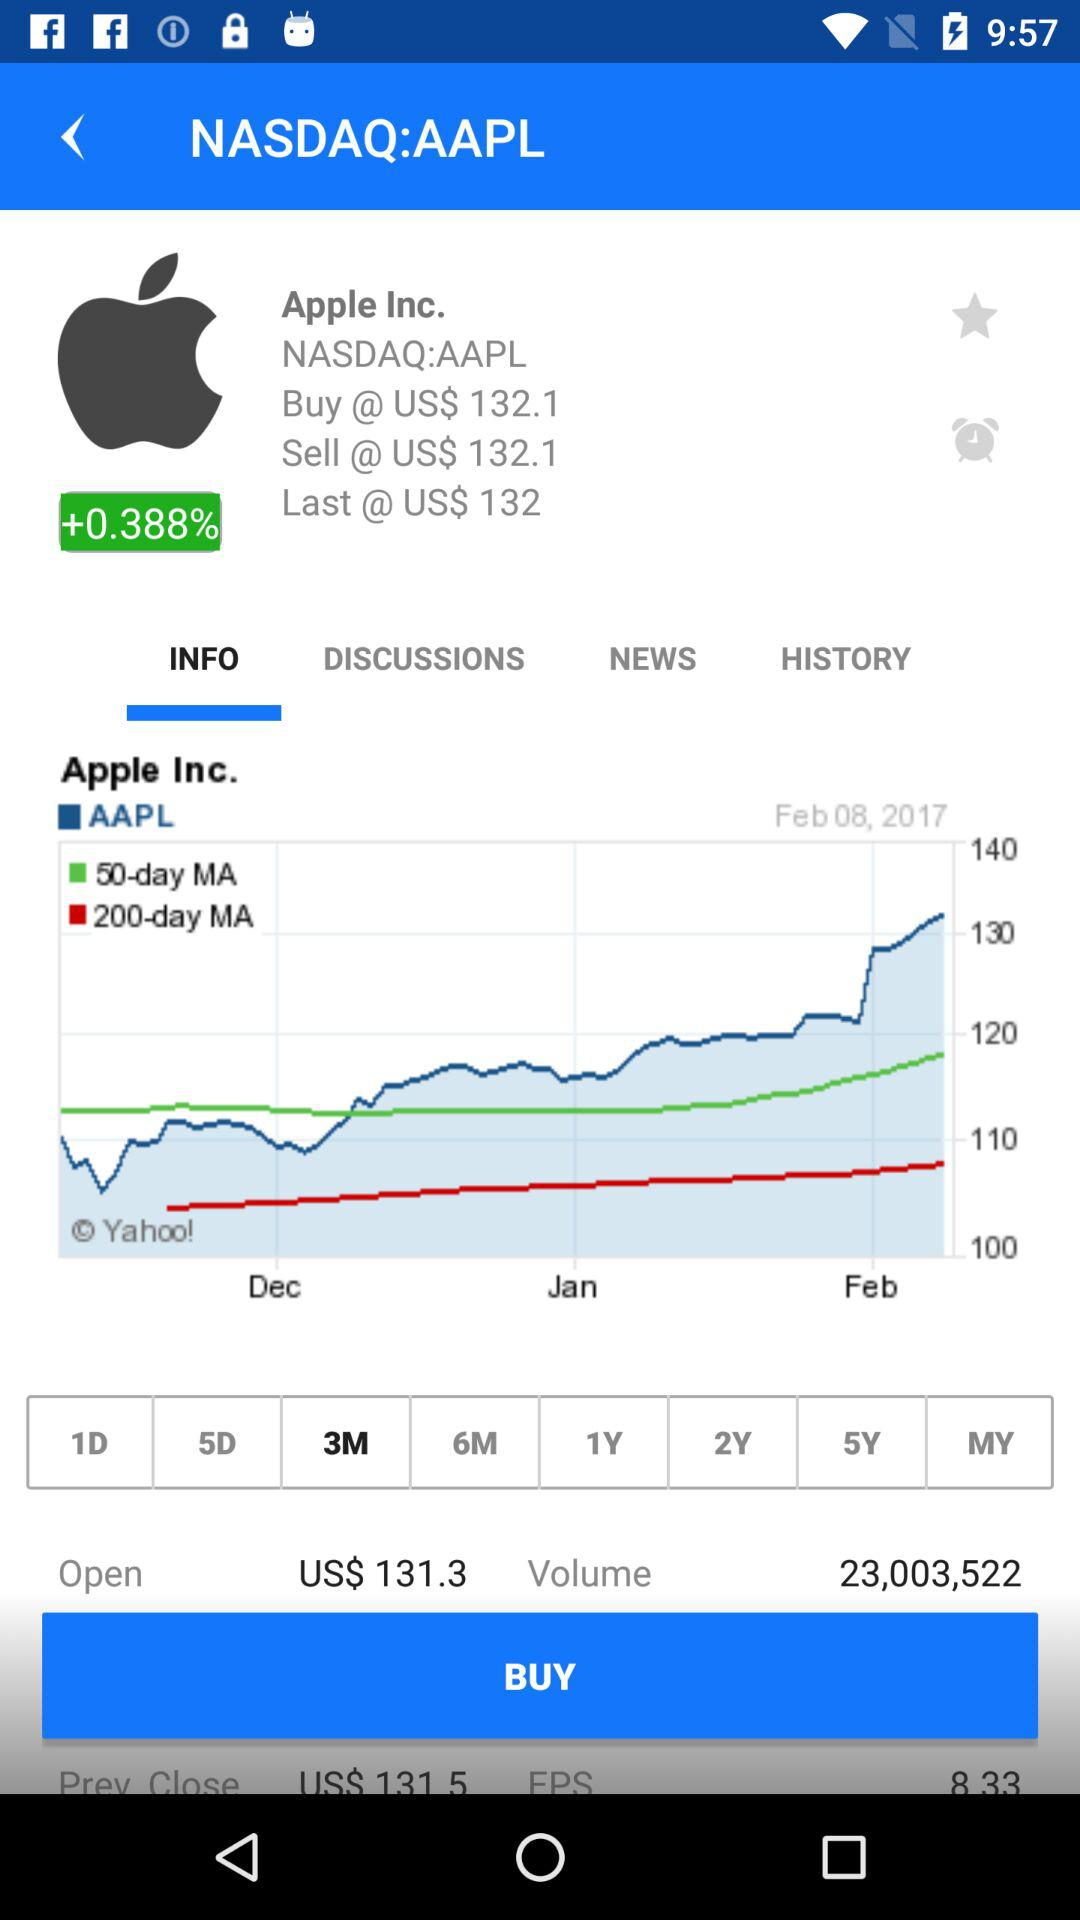How much is the buying price of AAPL in dollars? The buying price of AAPL is US$132.1. 